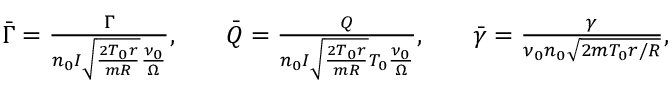Convert formula to latex. <formula><loc_0><loc_0><loc_500><loc_500>\begin{array} { r l r l r } { \bar { \Gamma } = \frac { \Gamma } { n _ { 0 } I \sqrt { \frac { 2 T _ { 0 } r } { m R } } \frac { \nu _ { 0 } } { \Omega } } , } & { \bar { Q } = \frac { Q } { n _ { 0 } I \sqrt { \frac { 2 T _ { 0 } r } { m R } } T _ { 0 } \frac { \nu _ { 0 } } { \Omega } } , } & { \bar { \gamma } = \frac { \gamma } { \nu _ { 0 } n _ { 0 } \sqrt { 2 m T _ { 0 } r / R } } , } \end{array}</formula> 